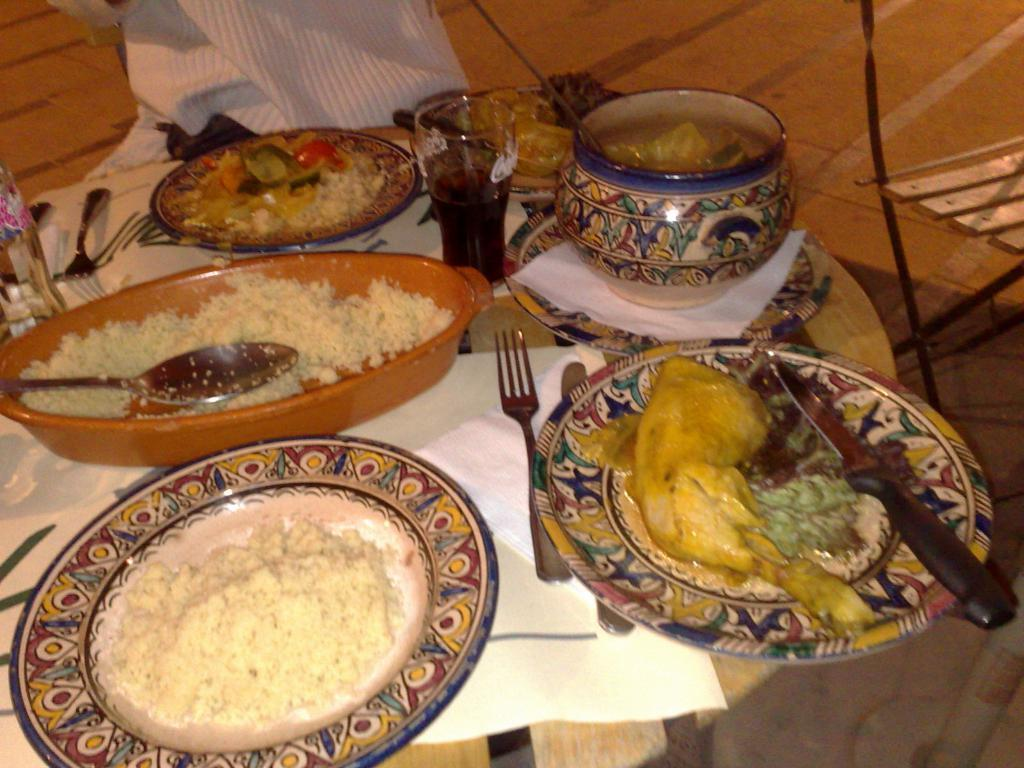What type of food items can be seen on the plates in the image? There are plates with food items in the image, but the specific types of food cannot be determined from the facts provided. What is in the glass in the image? There is a glass with a drink in the image, but the type of drink cannot be determined from the facts provided. What can be used for cleaning or wiping in the image? Tissue papers are present in the image for cleaning or wiping. What utensils are visible in the image? There are forks and knives in the image. What is the surface on which all these items are placed? All these items are placed on a surface, but the specific type of surface cannot be determined from the facts provided. How many forks are there in the image? The facts provided do not specify the number of forks in the image. What type of animal is present in the image? There is no mention of any animal in the image or the provided facts. 